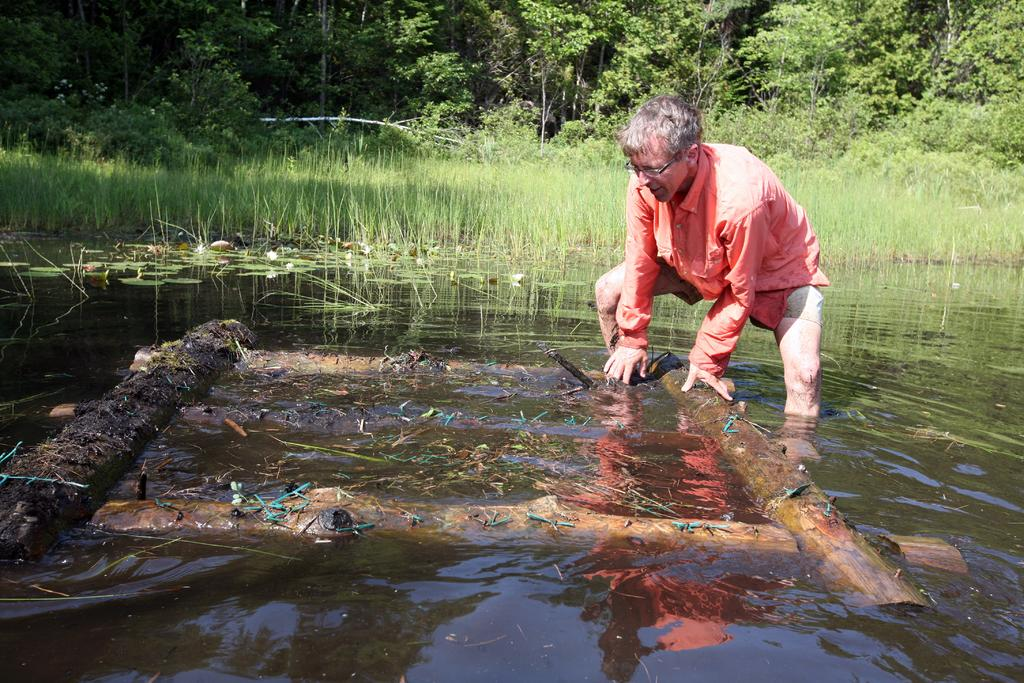What is at the bottom of the image? There is water at the bottom of the image. What is the person in the image doing? The person is standing in the water. What object is the person holding? The person is holding a raft. What can be seen in the background of the image? There are trees visible behind the person. What invention is the person using to crush the trees in the background? There is no invention or tree-crushing activity depicted in the image. 